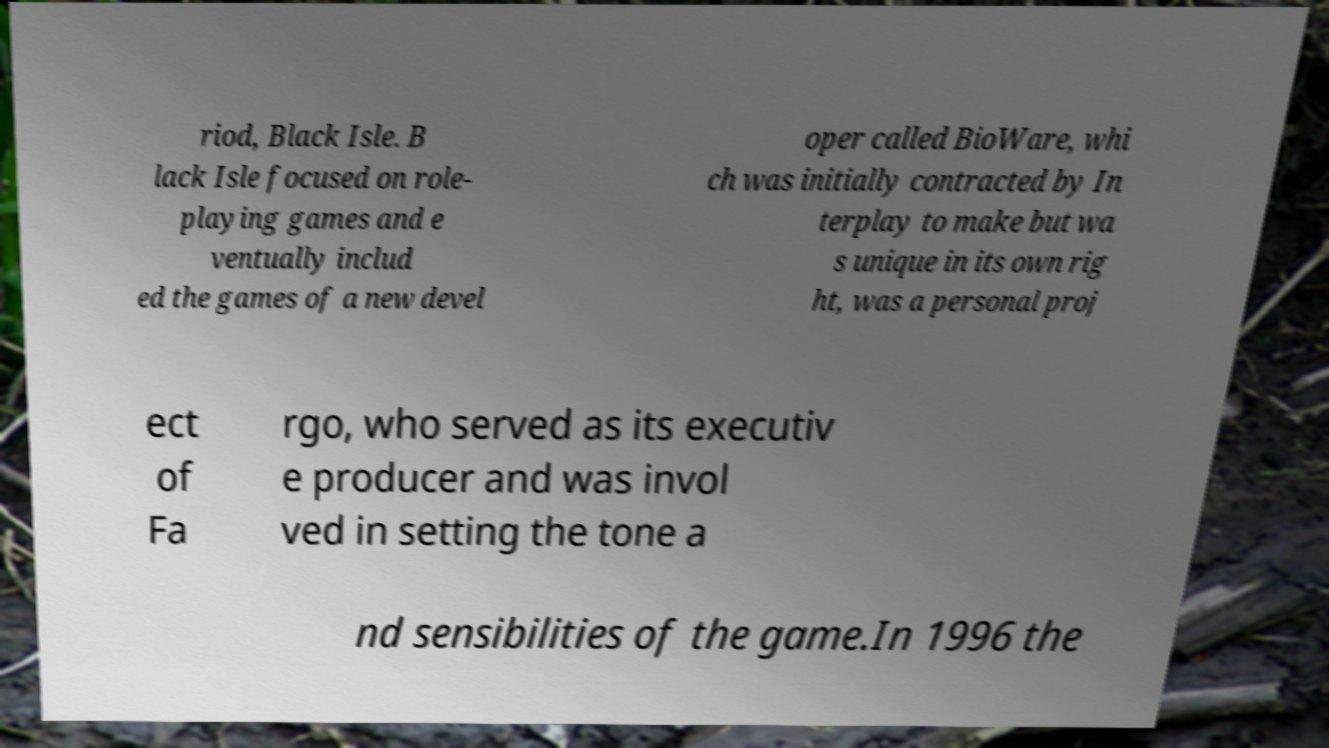Please identify and transcribe the text found in this image. riod, Black Isle. B lack Isle focused on role- playing games and e ventually includ ed the games of a new devel oper called BioWare, whi ch was initially contracted by In terplay to make but wa s unique in its own rig ht, was a personal proj ect of Fa rgo, who served as its executiv e producer and was invol ved in setting the tone a nd sensibilities of the game.In 1996 the 